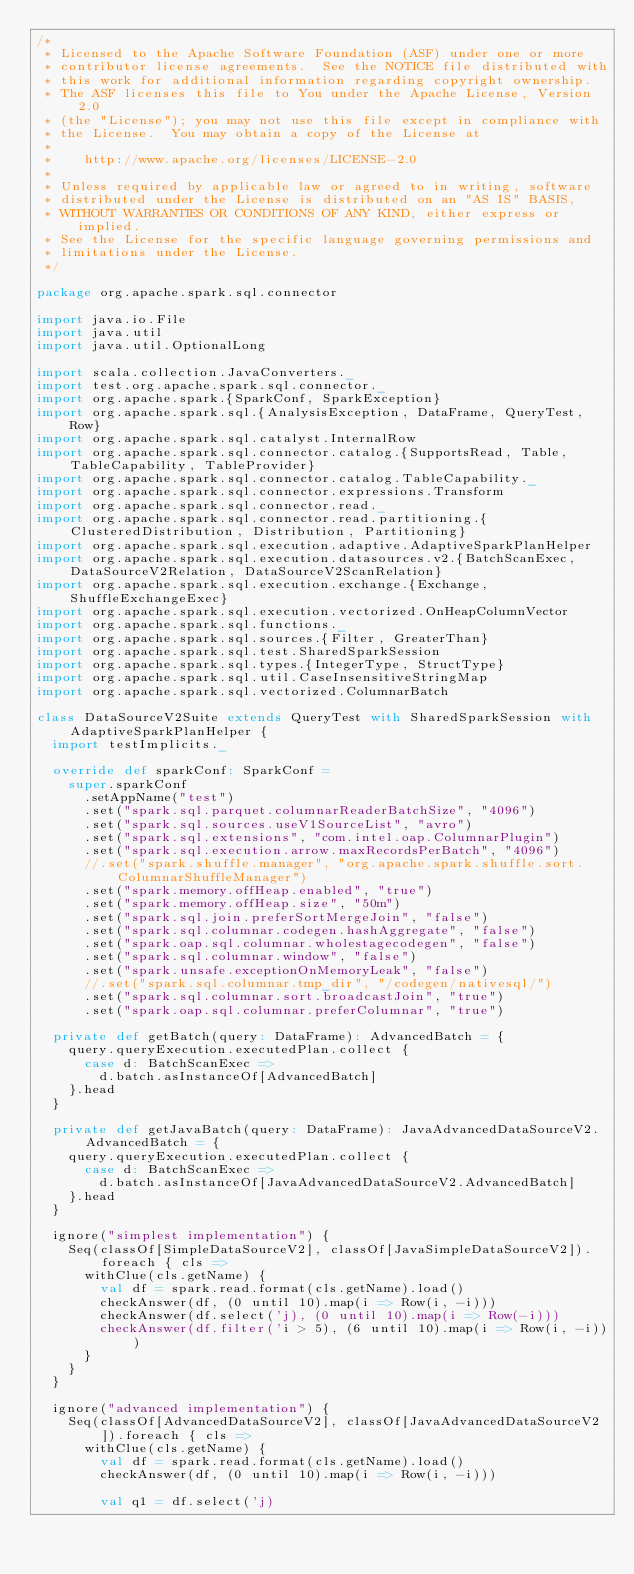Convert code to text. <code><loc_0><loc_0><loc_500><loc_500><_Scala_>/*
 * Licensed to the Apache Software Foundation (ASF) under one or more
 * contributor license agreements.  See the NOTICE file distributed with
 * this work for additional information regarding copyright ownership.
 * The ASF licenses this file to You under the Apache License, Version 2.0
 * (the "License"); you may not use this file except in compliance with
 * the License.  You may obtain a copy of the License at
 *
 *    http://www.apache.org/licenses/LICENSE-2.0
 *
 * Unless required by applicable law or agreed to in writing, software
 * distributed under the License is distributed on an "AS IS" BASIS,
 * WITHOUT WARRANTIES OR CONDITIONS OF ANY KIND, either express or implied.
 * See the License for the specific language governing permissions and
 * limitations under the License.
 */

package org.apache.spark.sql.connector

import java.io.File
import java.util
import java.util.OptionalLong

import scala.collection.JavaConverters._
import test.org.apache.spark.sql.connector._
import org.apache.spark.{SparkConf, SparkException}
import org.apache.spark.sql.{AnalysisException, DataFrame, QueryTest, Row}
import org.apache.spark.sql.catalyst.InternalRow
import org.apache.spark.sql.connector.catalog.{SupportsRead, Table, TableCapability, TableProvider}
import org.apache.spark.sql.connector.catalog.TableCapability._
import org.apache.spark.sql.connector.expressions.Transform
import org.apache.spark.sql.connector.read._
import org.apache.spark.sql.connector.read.partitioning.{ClusteredDistribution, Distribution, Partitioning}
import org.apache.spark.sql.execution.adaptive.AdaptiveSparkPlanHelper
import org.apache.spark.sql.execution.datasources.v2.{BatchScanExec, DataSourceV2Relation, DataSourceV2ScanRelation}
import org.apache.spark.sql.execution.exchange.{Exchange, ShuffleExchangeExec}
import org.apache.spark.sql.execution.vectorized.OnHeapColumnVector
import org.apache.spark.sql.functions._
import org.apache.spark.sql.sources.{Filter, GreaterThan}
import org.apache.spark.sql.test.SharedSparkSession
import org.apache.spark.sql.types.{IntegerType, StructType}
import org.apache.spark.sql.util.CaseInsensitiveStringMap
import org.apache.spark.sql.vectorized.ColumnarBatch

class DataSourceV2Suite extends QueryTest with SharedSparkSession with AdaptiveSparkPlanHelper {
  import testImplicits._

  override def sparkConf: SparkConf =
    super.sparkConf
      .setAppName("test")
      .set("spark.sql.parquet.columnarReaderBatchSize", "4096")
      .set("spark.sql.sources.useV1SourceList", "avro")
      .set("spark.sql.extensions", "com.intel.oap.ColumnarPlugin")
      .set("spark.sql.execution.arrow.maxRecordsPerBatch", "4096")
      //.set("spark.shuffle.manager", "org.apache.spark.shuffle.sort.ColumnarShuffleManager")
      .set("spark.memory.offHeap.enabled", "true")
      .set("spark.memory.offHeap.size", "50m")
      .set("spark.sql.join.preferSortMergeJoin", "false")
      .set("spark.sql.columnar.codegen.hashAggregate", "false")
      .set("spark.oap.sql.columnar.wholestagecodegen", "false")
      .set("spark.sql.columnar.window", "false")
      .set("spark.unsafe.exceptionOnMemoryLeak", "false")
      //.set("spark.sql.columnar.tmp_dir", "/codegen/nativesql/")
      .set("spark.sql.columnar.sort.broadcastJoin", "true")
      .set("spark.oap.sql.columnar.preferColumnar", "true")

  private def getBatch(query: DataFrame): AdvancedBatch = {
    query.queryExecution.executedPlan.collect {
      case d: BatchScanExec =>
        d.batch.asInstanceOf[AdvancedBatch]
    }.head
  }

  private def getJavaBatch(query: DataFrame): JavaAdvancedDataSourceV2.AdvancedBatch = {
    query.queryExecution.executedPlan.collect {
      case d: BatchScanExec =>
        d.batch.asInstanceOf[JavaAdvancedDataSourceV2.AdvancedBatch]
    }.head
  }

  ignore("simplest implementation") {
    Seq(classOf[SimpleDataSourceV2], classOf[JavaSimpleDataSourceV2]).foreach { cls =>
      withClue(cls.getName) {
        val df = spark.read.format(cls.getName).load()
        checkAnswer(df, (0 until 10).map(i => Row(i, -i)))
        checkAnswer(df.select('j), (0 until 10).map(i => Row(-i)))
        checkAnswer(df.filter('i > 5), (6 until 10).map(i => Row(i, -i)))
      }
    }
  }

  ignore("advanced implementation") {
    Seq(classOf[AdvancedDataSourceV2], classOf[JavaAdvancedDataSourceV2]).foreach { cls =>
      withClue(cls.getName) {
        val df = spark.read.format(cls.getName).load()
        checkAnswer(df, (0 until 10).map(i => Row(i, -i)))

        val q1 = df.select('j)</code> 